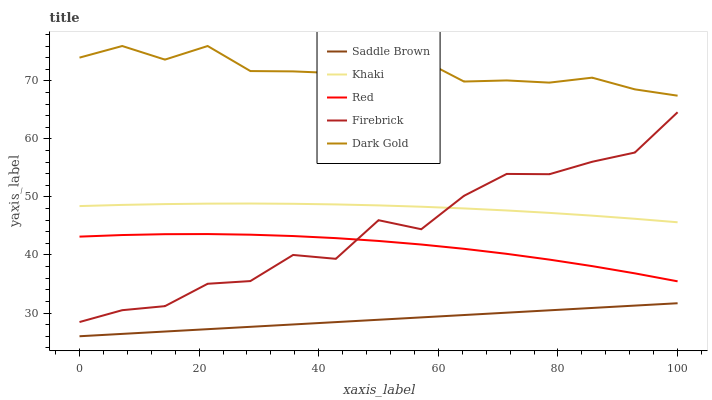Does Khaki have the minimum area under the curve?
Answer yes or no. No. Does Khaki have the maximum area under the curve?
Answer yes or no. No. Is Khaki the smoothest?
Answer yes or no. No. Is Khaki the roughest?
Answer yes or no. No. Does Khaki have the lowest value?
Answer yes or no. No. Does Khaki have the highest value?
Answer yes or no. No. Is Saddle Brown less than Khaki?
Answer yes or no. Yes. Is Khaki greater than Saddle Brown?
Answer yes or no. Yes. Does Saddle Brown intersect Khaki?
Answer yes or no. No. 